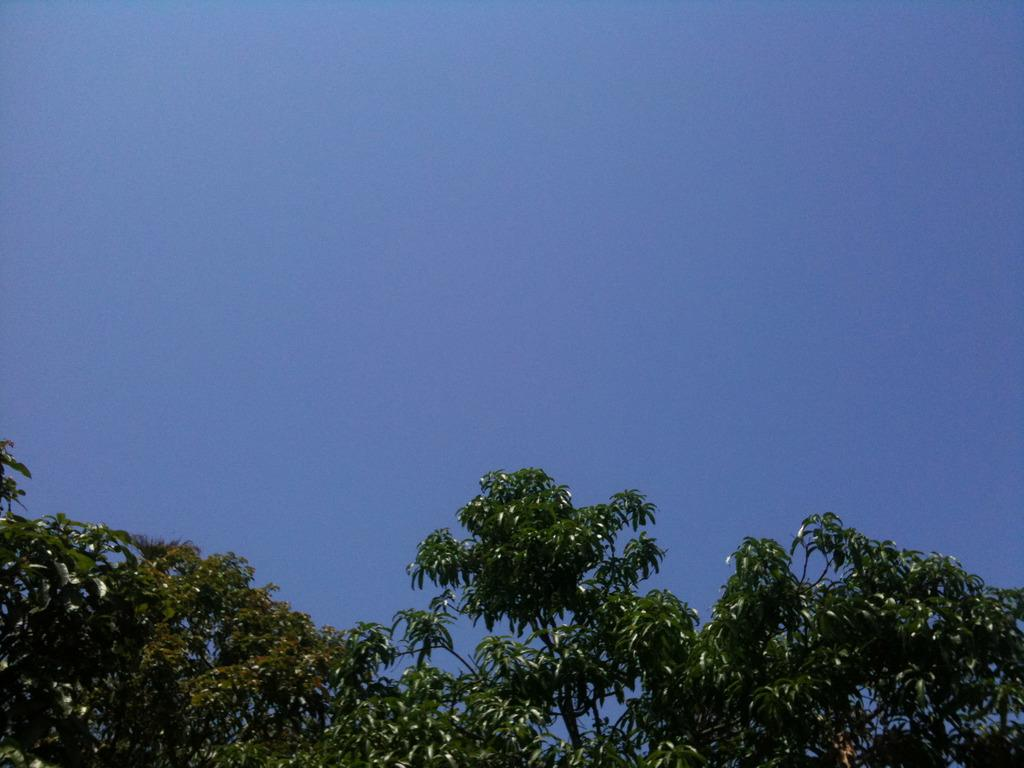What type of vegetation is present at the bottom of the image? There are trees at the bottom of the image. What part of the natural environment is visible in the background of the image? The sky is visible in the background of the image. Can you see an owl perched on one of the trees in the image? There is no owl present in the image; only trees and the sky are visible. What afterthought might the artist have had while creating this image? We cannot determine any afterthoughts the artist may have had, as we are only looking at the final image and not the creative process. 